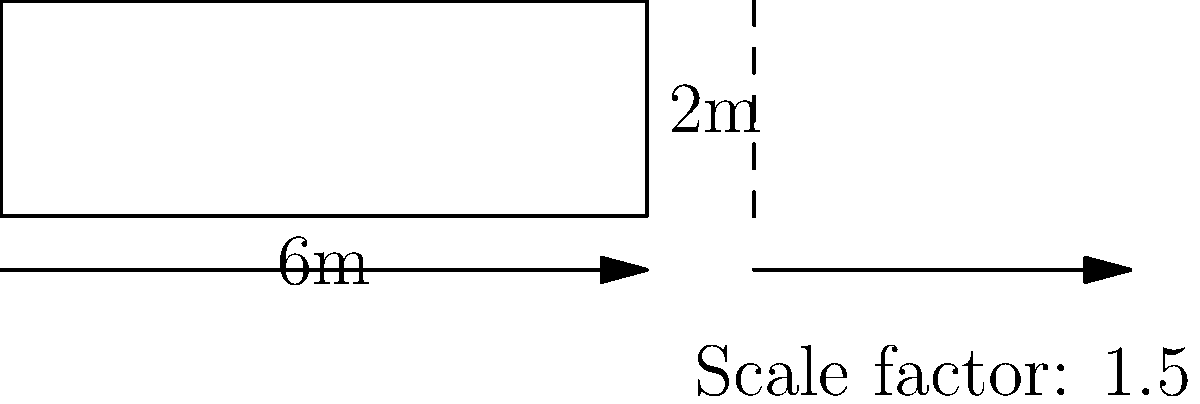A wheelchair ramp at a railway station has dimensions of 6m in length and 2m in height. To improve accessibility, the ramp needs to be scaled up by a factor of 1.5. What will be the new length and height of the ramp after scaling? To solve this problem, we need to apply the scaling factor to both dimensions of the ramp:

1. Original dimensions:
   - Length: 6m
   - Height: 2m

2. Scaling factor: 1.5

3. Calculate the new length:
   $\text{New length} = \text{Original length} \times \text{Scaling factor}$
   $\text{New length} = 6m \times 1.5 = 9m$

4. Calculate the new height:
   $\text{New height} = \text{Original height} \times \text{Scaling factor}$
   $\text{New height} = 2m \times 1.5 = 3m$

Therefore, after scaling, the new dimensions of the ramp will be 9m in length and 3m in height.
Answer: 9m length, 3m height 